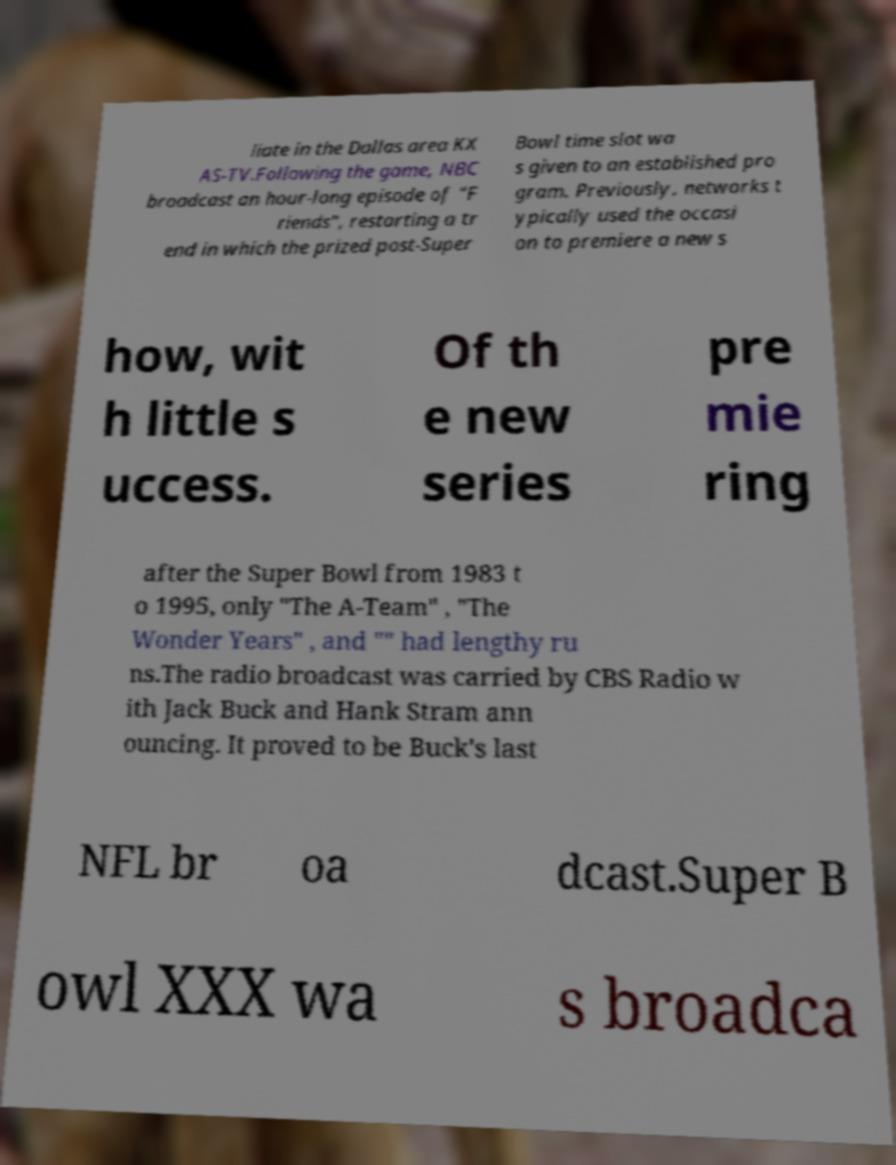I need the written content from this picture converted into text. Can you do that? liate in the Dallas area KX AS-TV.Following the game, NBC broadcast an hour-long episode of "F riends", restarting a tr end in which the prized post-Super Bowl time slot wa s given to an established pro gram. Previously, networks t ypically used the occasi on to premiere a new s how, wit h little s uccess. Of th e new series pre mie ring after the Super Bowl from 1983 t o 1995, only "The A-Team" , "The Wonder Years" , and "" had lengthy ru ns.The radio broadcast was carried by CBS Radio w ith Jack Buck and Hank Stram ann ouncing. It proved to be Buck's last NFL br oa dcast.Super B owl XXX wa s broadca 